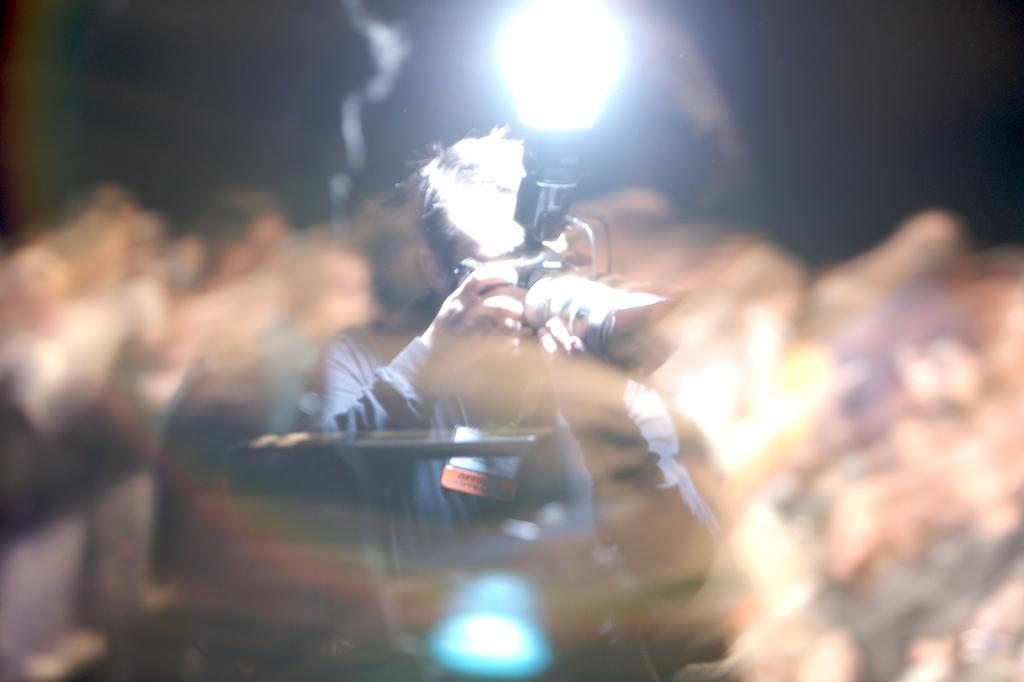What is the main subject of the image? There is a person in the image. What is the person holding in the image? The person is holding a digital camera. Can you describe the background of the image? The background of the image is blurry. What can be seen at the top of the image? There is a flash visible at the top of the image. How many jellyfish are swimming in the background of the image? There are no jellyfish present in the image; the background is blurry. What type of smoke can be seen coming from the person's camera in the image? There is no smoke visible in the image; only a flash is present at the top of the image. 